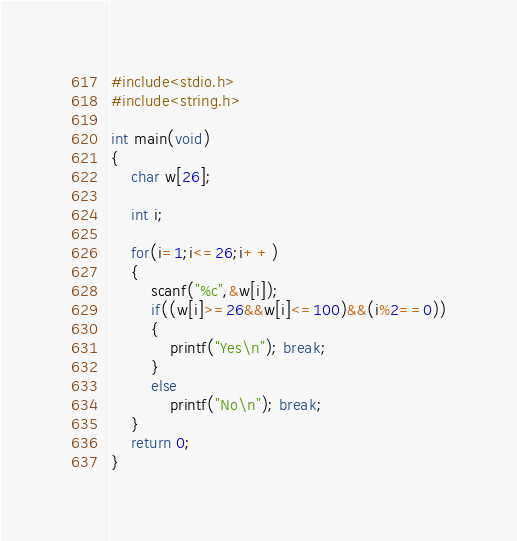<code> <loc_0><loc_0><loc_500><loc_500><_C_>#include<stdio.h>
#include<string.h>

int main(void)
{
    char w[26];

    int i;

    for(i=1;i<=26;i++)
    {
        scanf("%c",&w[i]);
        if((w[i]>=26&&w[i]<=100)&&(i%2==0))
        {
            printf("Yes\n"); break;
        }
        else
            printf("No\n"); break;
    }
    return 0;
}
</code> 